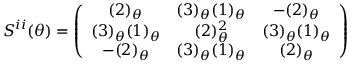Convert formula to latex. <formula><loc_0><loc_0><loc_500><loc_500>S ^ { i i } ( \theta ) = \left ( \begin{array} { c c c } { { ( 2 ) _ { \theta } } } & { { ( 3 ) _ { \theta } ( 1 ) _ { \theta } } } & { { - ( 2 ) _ { \theta } } } \\ { { ( 3 ) _ { \theta } ( 1 ) _ { \theta } } } & { { ( 2 ) _ { \theta } ^ { 2 } } } & { { ( 3 ) _ { \theta } ( 1 ) _ { \theta } } } \\ { { - ( 2 ) _ { \theta } } } & { { ( 3 ) _ { \theta } ( 1 ) _ { \theta } } } & { { ( 2 ) _ { \theta } } } \end{array} \right )</formula> 